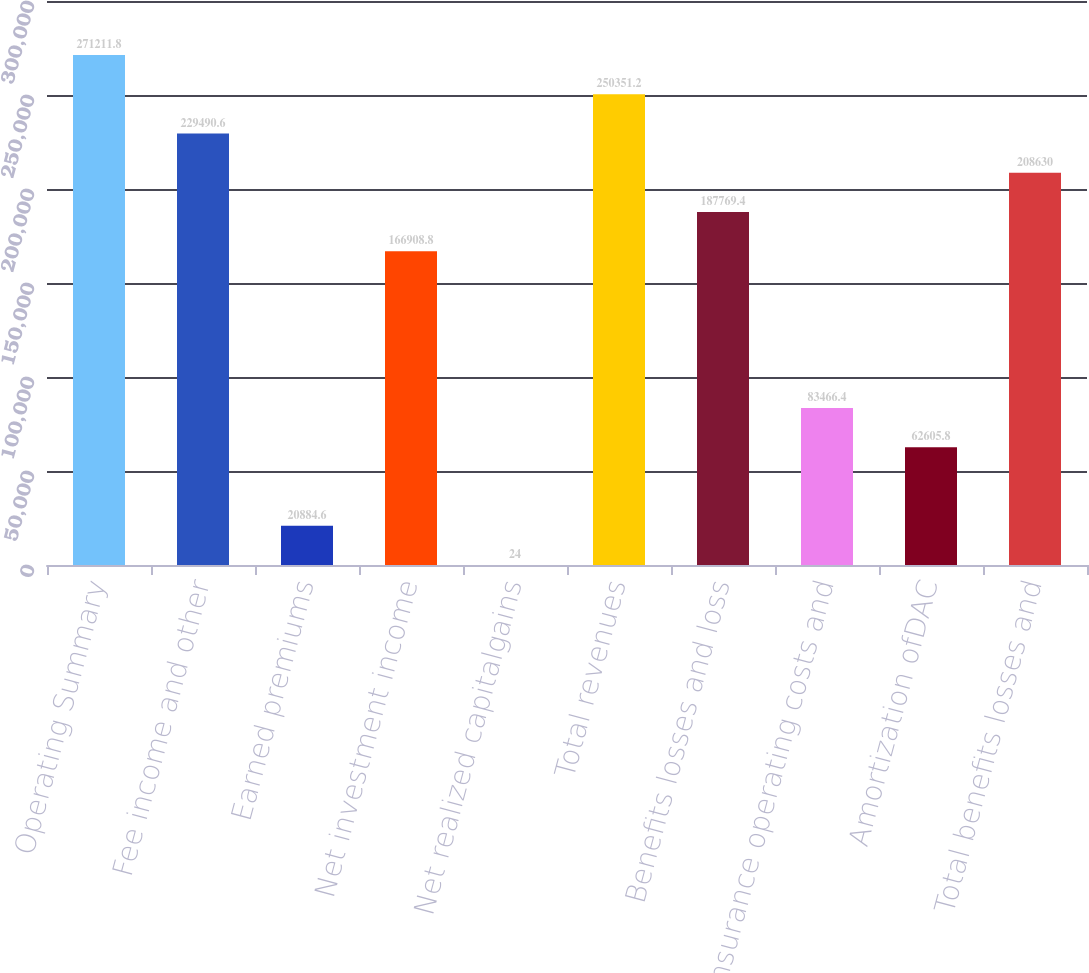Convert chart. <chart><loc_0><loc_0><loc_500><loc_500><bar_chart><fcel>Operating Summary<fcel>Fee income and other<fcel>Earned premiums<fcel>Net investment income<fcel>Net realized capitalgains<fcel>Total revenues<fcel>Benefits losses and loss<fcel>Insurance operating costs and<fcel>Amortization ofDAC<fcel>Total benefits losses and<nl><fcel>271212<fcel>229491<fcel>20884.6<fcel>166909<fcel>24<fcel>250351<fcel>187769<fcel>83466.4<fcel>62605.8<fcel>208630<nl></chart> 